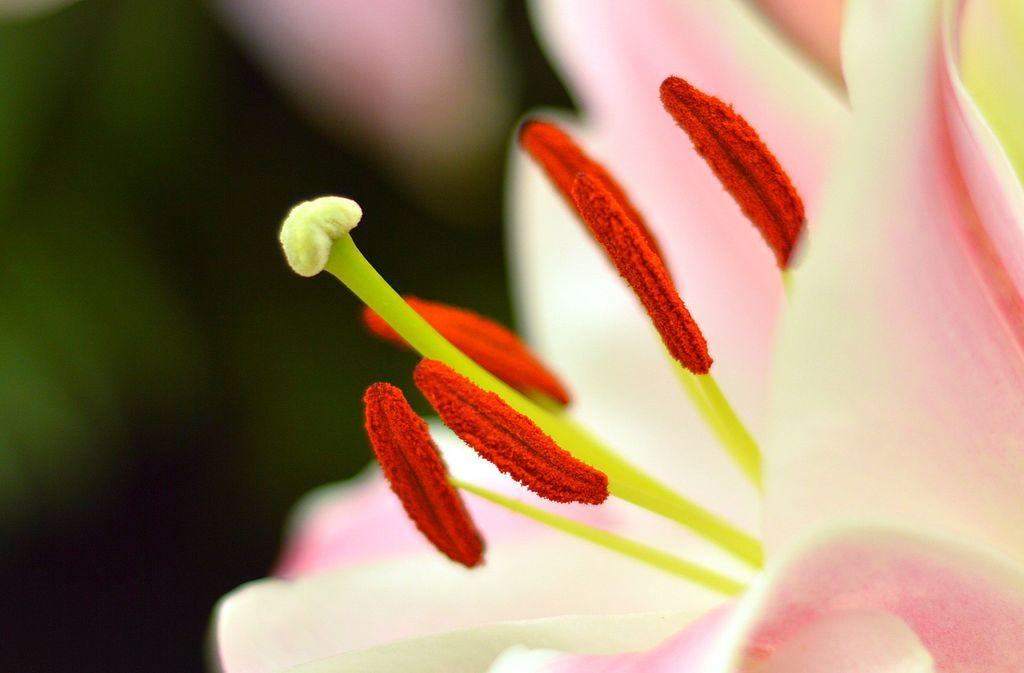What type of living organisms can be seen in the image? There are flowers in the image. Can you describe the background of the image? The background of the image is blurry. What type of jeans is the tramp wearing in the image? There is no tramp or jeans present in the image; it features flowers and a blurry background. What is the source of the flame in the image? There is no flame present in the image. 